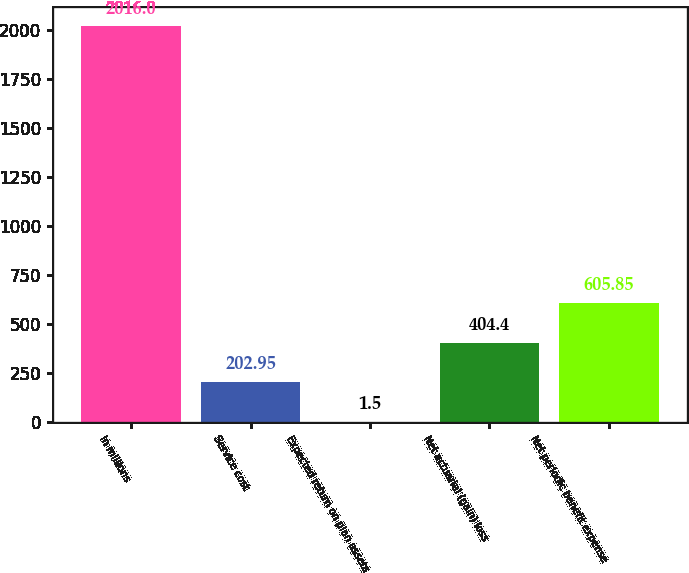Convert chart to OTSL. <chart><loc_0><loc_0><loc_500><loc_500><bar_chart><fcel>In millions<fcel>Service cost<fcel>Expected return on plan assets<fcel>Net actuarial (gain) loss<fcel>Net periodic benefit expense<nl><fcel>2016<fcel>202.95<fcel>1.5<fcel>404.4<fcel>605.85<nl></chart> 